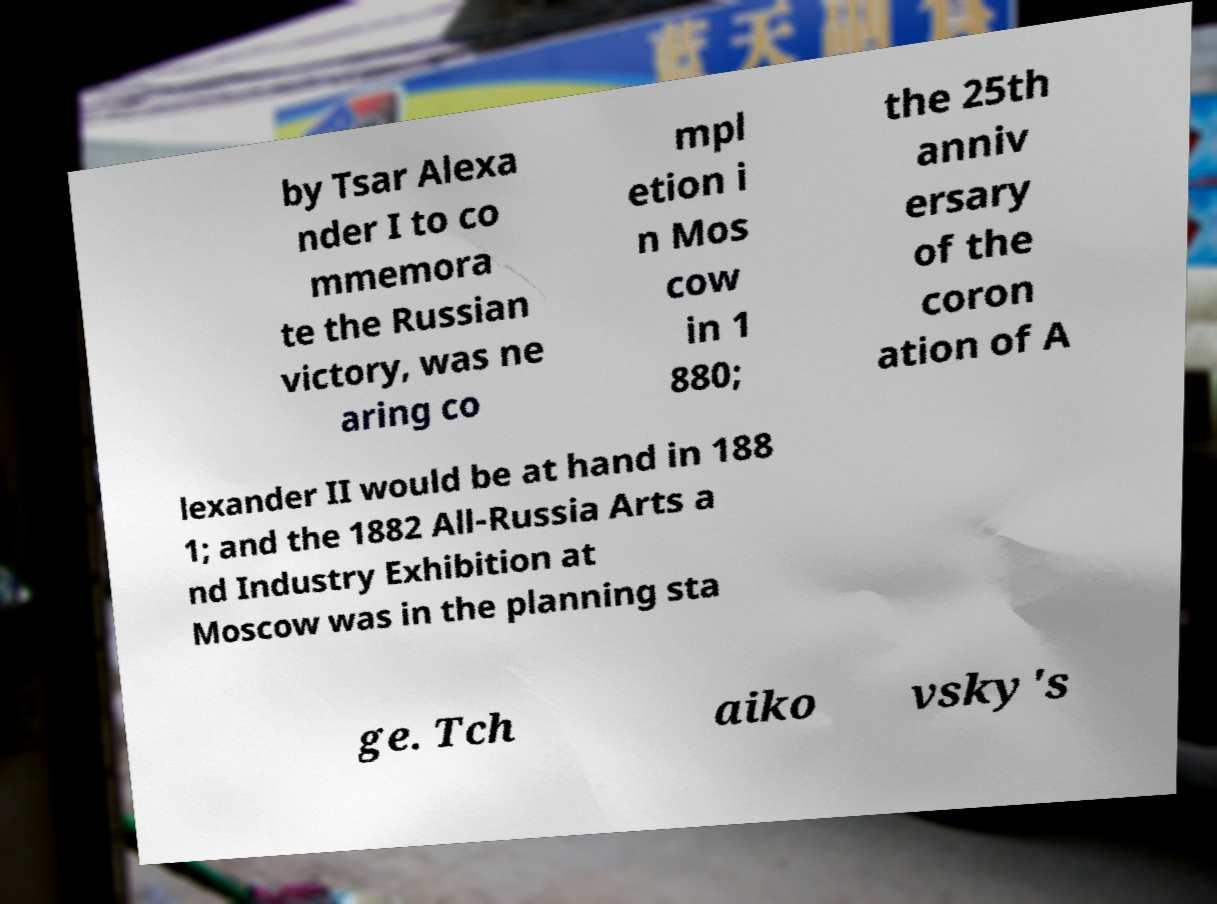There's text embedded in this image that I need extracted. Can you transcribe it verbatim? by Tsar Alexa nder I to co mmemora te the Russian victory, was ne aring co mpl etion i n Mos cow in 1 880; the 25th anniv ersary of the coron ation of A lexander II would be at hand in 188 1; and the 1882 All-Russia Arts a nd Industry Exhibition at Moscow was in the planning sta ge. Tch aiko vsky's 